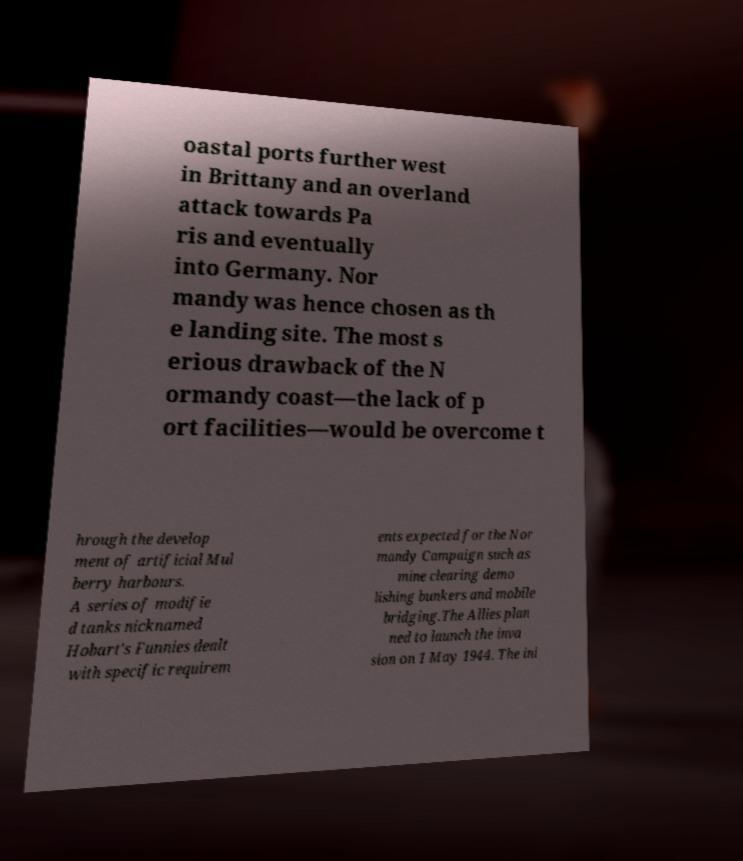Could you assist in decoding the text presented in this image and type it out clearly? oastal ports further west in Brittany and an overland attack towards Pa ris and eventually into Germany. Nor mandy was hence chosen as th e landing site. The most s erious drawback of the N ormandy coast—the lack of p ort facilities—would be overcome t hrough the develop ment of artificial Mul berry harbours. A series of modifie d tanks nicknamed Hobart's Funnies dealt with specific requirem ents expected for the Nor mandy Campaign such as mine clearing demo lishing bunkers and mobile bridging.The Allies plan ned to launch the inva sion on 1 May 1944. The ini 